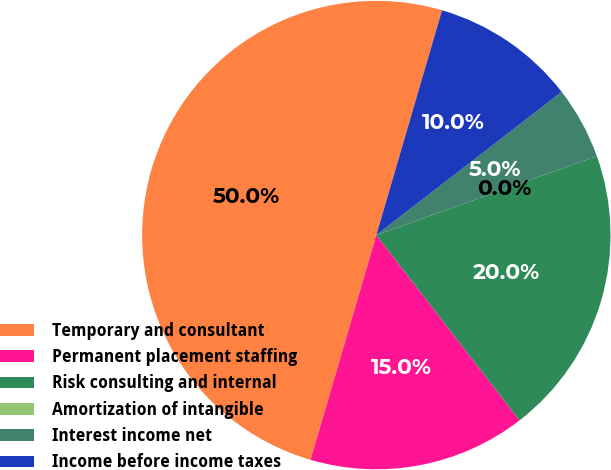<chart> <loc_0><loc_0><loc_500><loc_500><pie_chart><fcel>Temporary and consultant<fcel>Permanent placement staffing<fcel>Risk consulting and internal<fcel>Amortization of intangible<fcel>Interest income net<fcel>Income before income taxes<nl><fcel>49.99%<fcel>15.0%<fcel>20.0%<fcel>0.0%<fcel>5.0%<fcel>10.0%<nl></chart> 